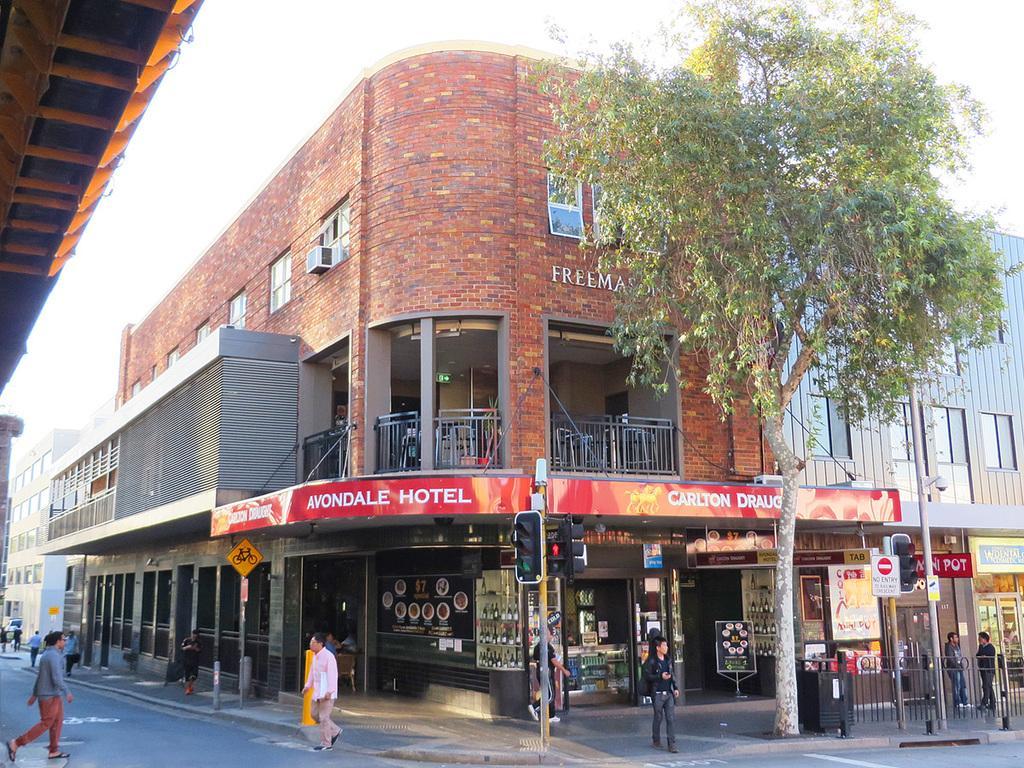Could you give a brief overview of what you see in this image? In the center of the image we can see buildings, air conditioner, wall, windows, railing, pole, sign boards, tree, stores, traffic light, some persons, poles, fencing, box. At the bottom of the image there is a road. At the top of the image we can see the sky. At the top left corner we can see the roof. 